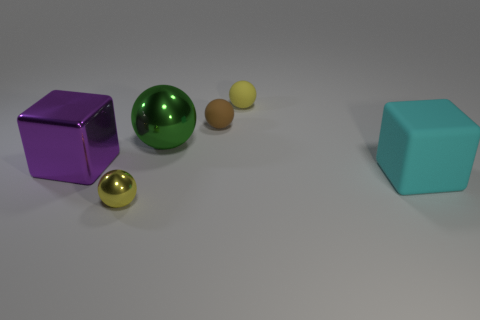Subtract all green spheres. How many spheres are left? 3 Subtract all brown balls. How many balls are left? 3 Subtract 1 balls. How many balls are left? 3 Subtract all cyan spheres. Subtract all green cubes. How many spheres are left? 4 Add 3 small yellow matte things. How many objects exist? 9 Subtract 0 purple spheres. How many objects are left? 6 Subtract all spheres. How many objects are left? 2 Subtract all tiny cylinders. Subtract all large objects. How many objects are left? 3 Add 6 big green balls. How many big green balls are left? 7 Add 2 brown matte balls. How many brown matte balls exist? 3 